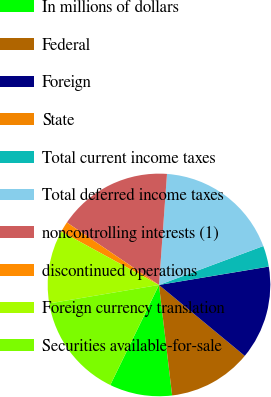<chart> <loc_0><loc_0><loc_500><loc_500><pie_chart><fcel>In millions of dollars<fcel>Federal<fcel>Foreign<fcel>State<fcel>Total current income taxes<fcel>Total deferred income taxes<fcel>noncontrolling interests (1)<fcel>discontinued operations<fcel>Foreign currency translation<fcel>Securities available-for-sale<nl><fcel>9.09%<fcel>12.12%<fcel>13.63%<fcel>0.01%<fcel>3.04%<fcel>18.17%<fcel>16.66%<fcel>1.53%<fcel>10.61%<fcel>15.14%<nl></chart> 